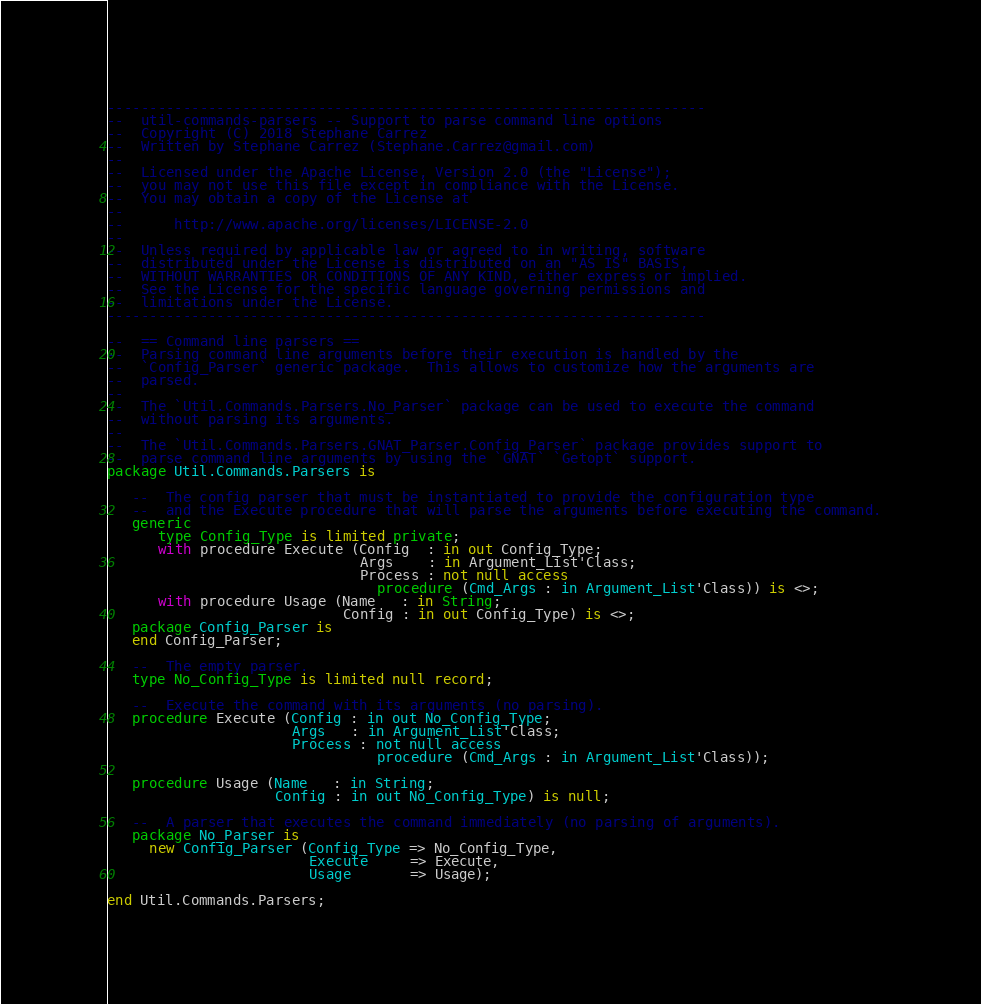<code> <loc_0><loc_0><loc_500><loc_500><_Ada_>-----------------------------------------------------------------------
--  util-commands-parsers -- Support to parse command line options
--  Copyright (C) 2018 Stephane Carrez
--  Written by Stephane Carrez (Stephane.Carrez@gmail.com)
--
--  Licensed under the Apache License, Version 2.0 (the "License");
--  you may not use this file except in compliance with the License.
--  You may obtain a copy of the License at
--
--      http://www.apache.org/licenses/LICENSE-2.0
--
--  Unless required by applicable law or agreed to in writing, software
--  distributed under the License is distributed on an "AS IS" BASIS,
--  WITHOUT WARRANTIES OR CONDITIONS OF ANY KIND, either express or implied.
--  See the License for the specific language governing permissions and
--  limitations under the License.
-----------------------------------------------------------------------

--  == Command line parsers ==
--  Parsing command line arguments before their execution is handled by the
--  `Config_Parser` generic package.  This allows to customize how the arguments are
--  parsed.
--
--  The `Util.Commands.Parsers.No_Parser` package can be used to execute the command
--  without parsing its arguments.
--
--  The `Util.Commands.Parsers.GNAT_Parser.Config_Parser` package provides support to
--  parse command line arguments by using the `GNAT` `Getopt` support.
package Util.Commands.Parsers is

   --  The config parser that must be instantiated to provide the configuration type
   --  and the Execute procedure that will parse the arguments before executing the command.
   generic
      type Config_Type is limited private;
      with procedure Execute (Config  : in out Config_Type;
                              Args    : in Argument_List'Class;
                              Process : not null access
                                procedure (Cmd_Args : in Argument_List'Class)) is <>;
      with procedure Usage (Name   : in String;
                            Config : in out Config_Type) is <>;
   package Config_Parser is
   end Config_Parser;

   --  The empty parser.
   type No_Config_Type is limited null record;

   --  Execute the command with its arguments (no parsing).
   procedure Execute (Config : in out No_Config_Type;
                      Args   : in Argument_List'Class;
                      Process : not null access
                                procedure (Cmd_Args : in Argument_List'Class));

   procedure Usage (Name   : in String;
                    Config : in out No_Config_Type) is null;

   --  A parser that executes the command immediately (no parsing of arguments).
   package No_Parser is
     new Config_Parser (Config_Type => No_Config_Type,
                        Execute     => Execute,
                        Usage       => Usage);

end Util.Commands.Parsers;
</code> 